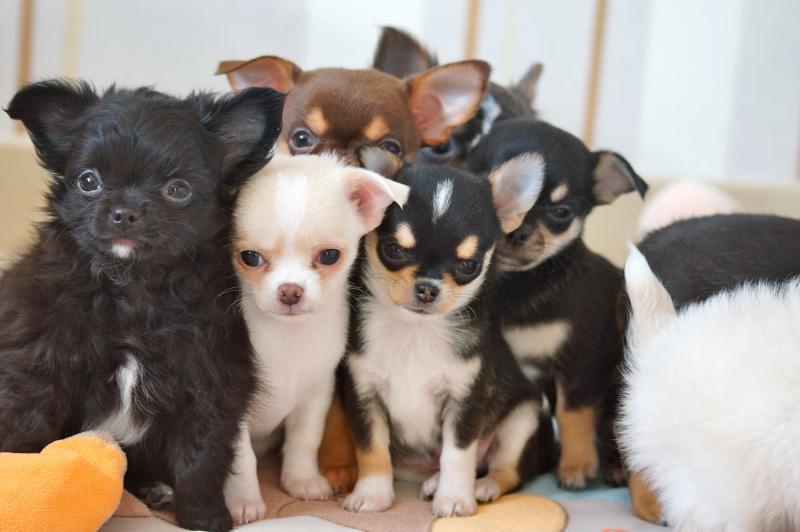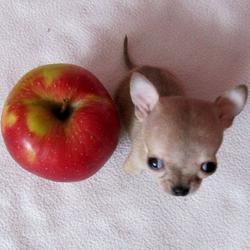The first image is the image on the left, the second image is the image on the right. For the images shown, is this caption "There is a single all white dog in the image on the right." true? Answer yes or no. No. The first image is the image on the left, the second image is the image on the right. Given the left and right images, does the statement "A small dog is sitting next to a red object." hold true? Answer yes or no. Yes. 